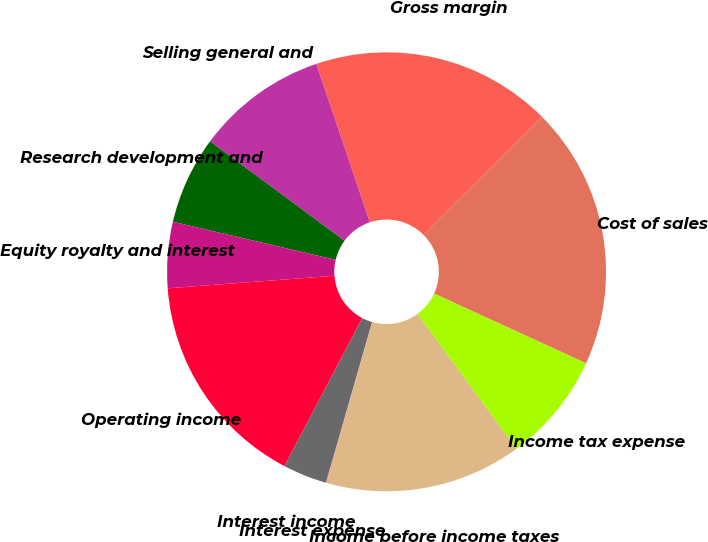Convert chart. <chart><loc_0><loc_0><loc_500><loc_500><pie_chart><fcel>Cost of sales<fcel>Gross margin<fcel>Selling general and<fcel>Research development and<fcel>Equity royalty and interest<fcel>Operating income<fcel>Interest income<fcel>Interest expense<fcel>Income before income taxes<fcel>Income tax expense<nl><fcel>19.32%<fcel>17.71%<fcel>9.68%<fcel>6.47%<fcel>4.86%<fcel>16.1%<fcel>3.25%<fcel>0.04%<fcel>14.5%<fcel>8.07%<nl></chart> 